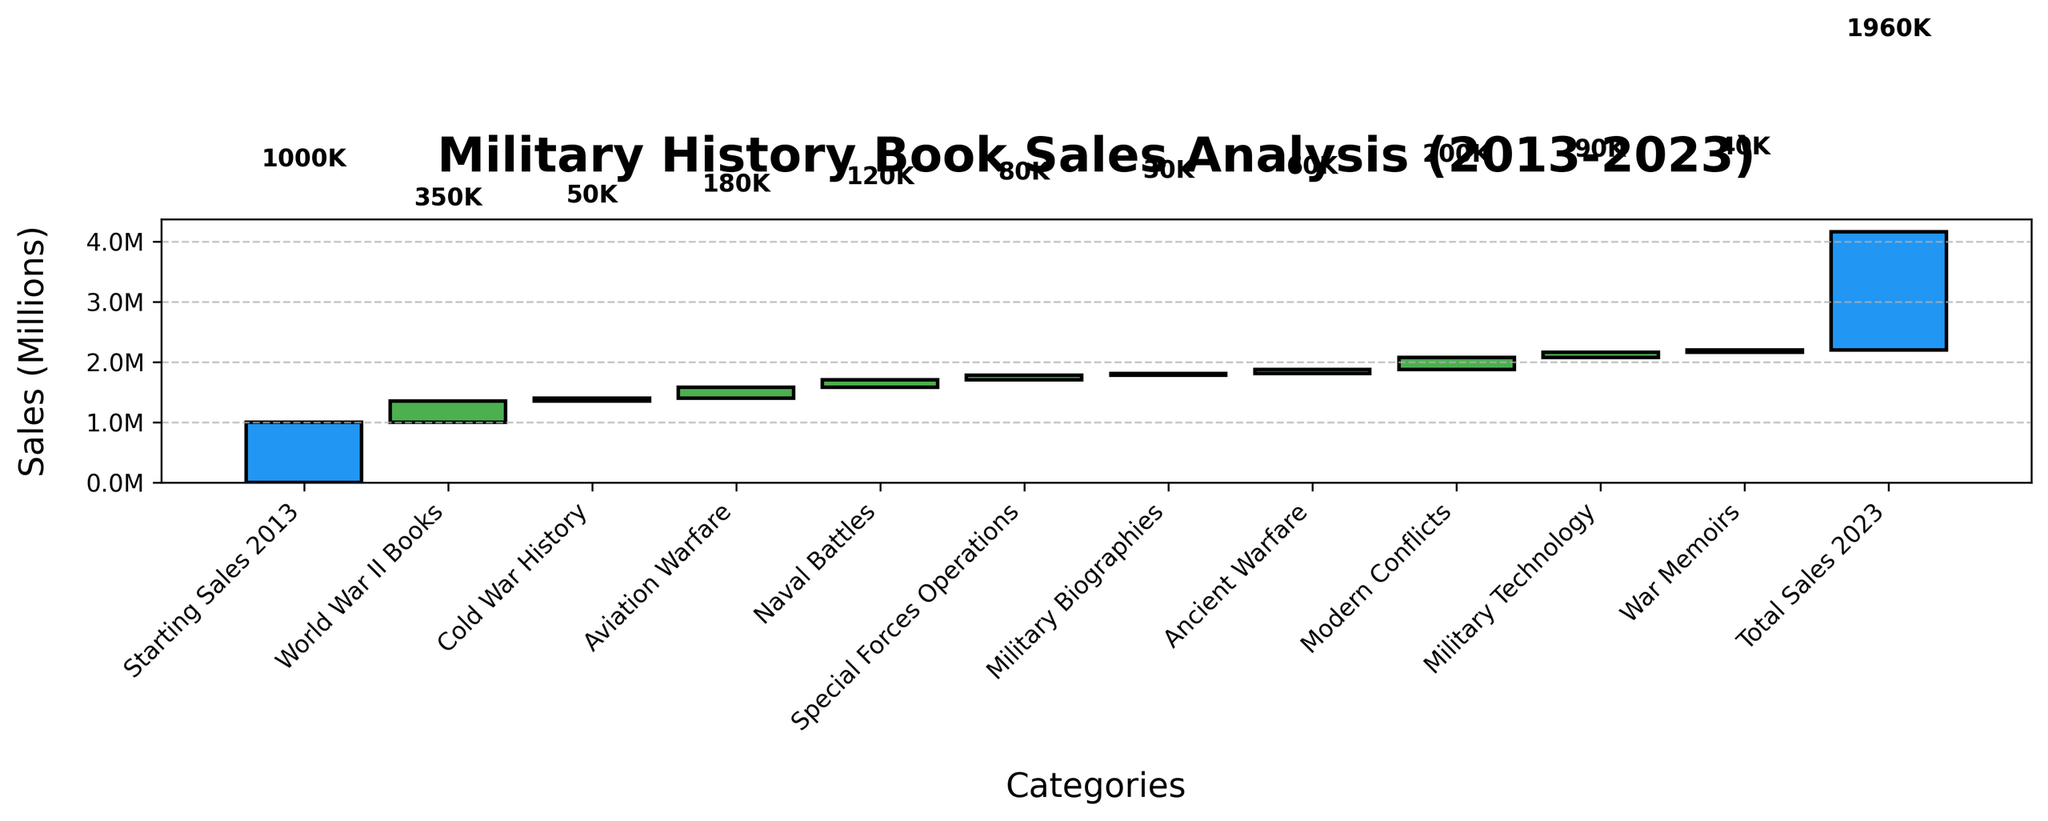How many categories have positive sales changes? Start by identifying the categories with positive sales changes. They are 'World War II Books', 'Aviation Warfare', 'Naval Battles', 'Special Forces Operations', 'Ancient Warfare', 'Modern Conflicts', and 'Military Technology'. Count these categories to get the answer.
Answer: 7 What is the total sales increase from the 'Modern Conflicts' and 'Military Technology' categories? The 'Modern Conflicts' category has an increase of 200,000 and 'Military Technology' has 90,000. Adding these two values: 200,000 + 90,000 = 290,000
Answer: 290,000 Which category had the most significant drop in sales? Look at the categories with negative values and identify the one with the largest decrease. 'Cold War History' decreased by 50,000, and 'War Memoirs' decreased by 40,000. The largest decrease is from 'Cold War History.'
Answer: Cold War History What is the final total sales value in 2023? Find the 'Total Sales 2023' bar on the chart, which is given as 1,960,000.
Answer: 1,960,000 Which two categories combined give the exact total increase in sales added by 'Aviation Warfare'? The 'Aviation Warfare' category increased by 180,000. Look for two categories that sum up to this value. 'Naval Battles' (120,000) and 'Special Forces Operations' (80,000) together give: 120,000 + 80,000 = 200,000, which doesn't match. However, 'Naval Battles' (120,000) and 'Ancient Warfare' (60,000) together: 120,000 + 60,000 = 180,000, which matches exactly.
Answer: Naval Battles and Ancient Warfare Which category had the smallest positive sales increase? Look for the categories with positive sales increases and identify the smallest one. 'Ancient Warfare' increased by 60,000.
Answer: Ancient Warfare What is the net change in sales from 'World War II Books' and 'Cold War History' categories combined? 'World War II Books' increased by 350,000, and 'Cold War History' decreased by 50,000. The net change is 350,000 - 50,000 = 300,000.
Answer: 300,000 How much did 'War Memoirs' decrease in sales? Identify the value associated with 'War Memoirs' in the chart. It decreased by 40,000.
Answer: 40,000 